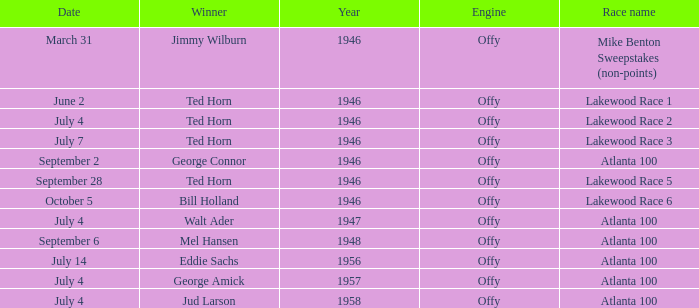Could you parse the entire table? {'header': ['Date', 'Winner', 'Year', 'Engine', 'Race name'], 'rows': [['March 31', 'Jimmy Wilburn', '1946', 'Offy', 'Mike Benton Sweepstakes (non-points)'], ['June 2', 'Ted Horn', '1946', 'Offy', 'Lakewood Race 1'], ['July 4', 'Ted Horn', '1946', 'Offy', 'Lakewood Race 2'], ['July 7', 'Ted Horn', '1946', 'Offy', 'Lakewood Race 3'], ['September 2', 'George Connor', '1946', 'Offy', 'Atlanta 100'], ['September 28', 'Ted Horn', '1946', 'Offy', 'Lakewood Race 5'], ['October 5', 'Bill Holland', '1946', 'Offy', 'Lakewood Race 6'], ['July 4', 'Walt Ader', '1947', 'Offy', 'Atlanta 100'], ['September 6', 'Mel Hansen', '1948', 'Offy', 'Atlanta 100'], ['July 14', 'Eddie Sachs', '1956', 'Offy', 'Atlanta 100'], ['July 4', 'George Amick', '1957', 'Offy', 'Atlanta 100'], ['July 4', 'Jud Larson', '1958', 'Offy', 'Atlanta 100']]} Which race did Bill Holland win in 1946? Lakewood Race 6. 